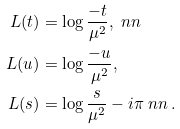Convert formula to latex. <formula><loc_0><loc_0><loc_500><loc_500>L ( t ) & = \log \frac { - t } { \mu ^ { 2 } } , \ n n \\ L ( u ) & = \log \frac { - u } { \mu ^ { 2 } } , \\ L ( s ) & = \log \frac { s } { \mu ^ { 2 } } - i \pi \ n n \, .</formula> 